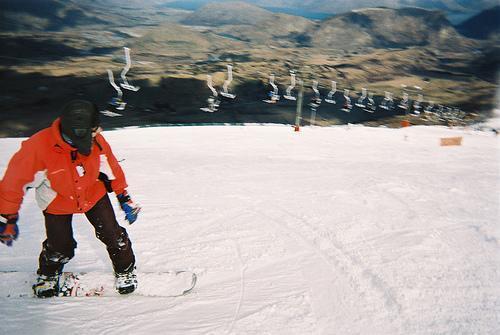How many people?
Give a very brief answer. 1. 